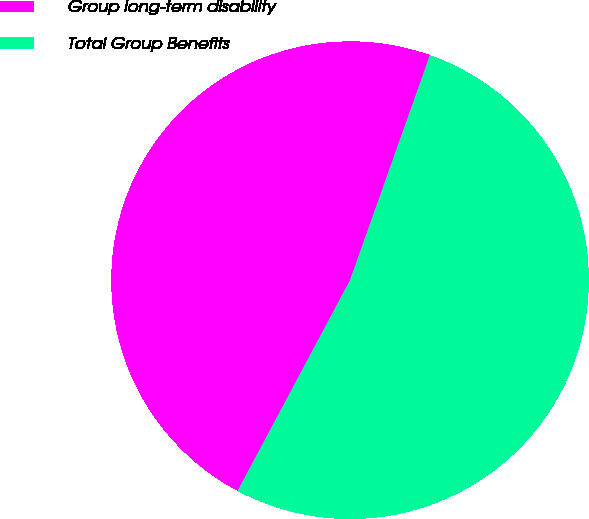<chart> <loc_0><loc_0><loc_500><loc_500><pie_chart><fcel>Group long-term disability<fcel>Total Group Benefits<nl><fcel>47.63%<fcel>52.37%<nl></chart> 